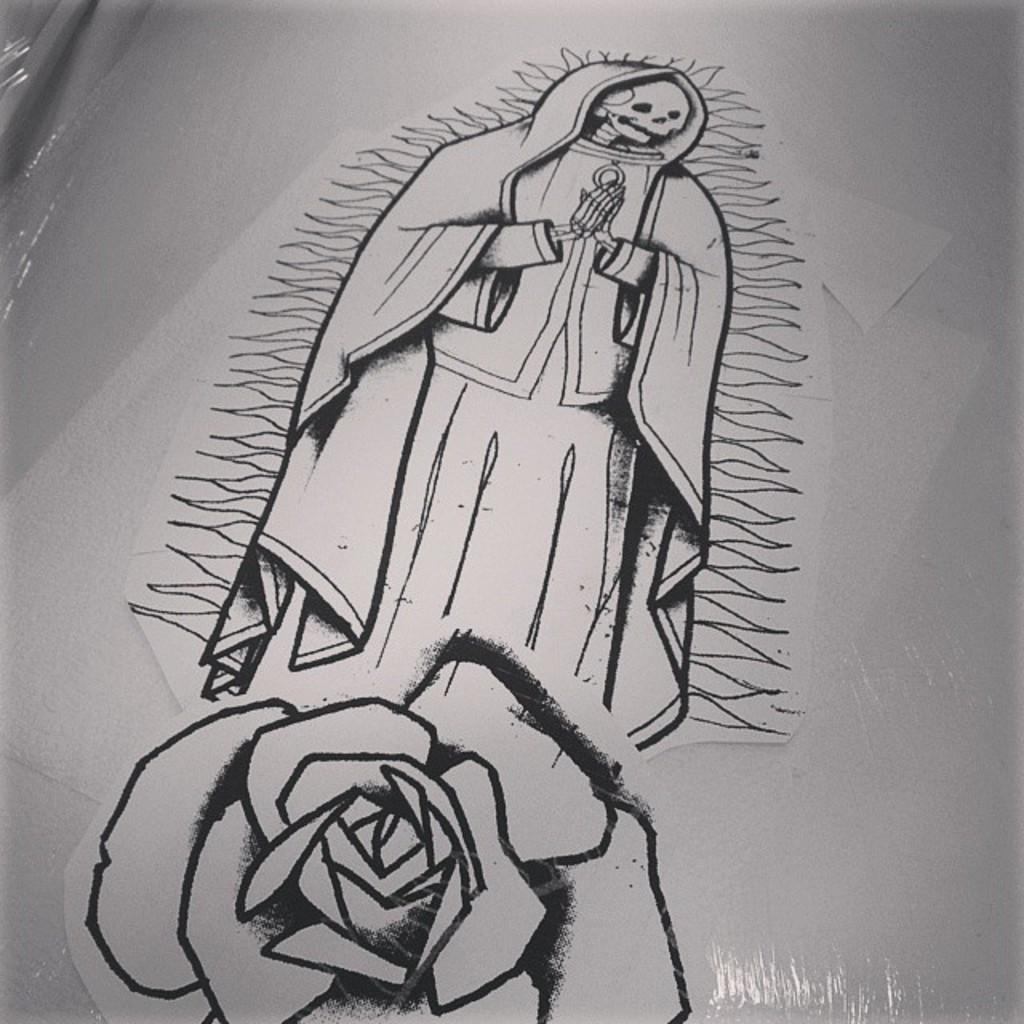What is the main subject of the sketch in the image? The main subject of the sketch cannot be determined from the provided facts. What is the color of the object on which the sketch is made? The object on which the sketch is made is white-colored. What else can be seen in the image besides the sketch? There is a cover visible in the image. What type of wrench is being used to adjust the unit in the image? There is no wrench or unit present in the image; it only features a sketch on a white-colored object and a cover. How many stockings are visible in the image? There are no stockings present in the image. 